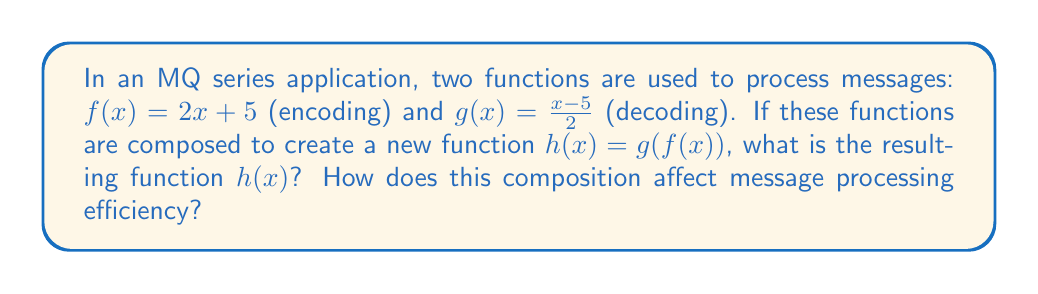Provide a solution to this math problem. To solve this problem, we need to compose the functions $f(x)$ and $g(x)$ to create $h(x)$:

1. Start with $h(x) = g(f(x))$
2. Replace $f(x)$ with its definition: $h(x) = g(2x + 5)$
3. Now apply function $g$ to this result:
   $h(x) = \frac{(2x + 5) - 5}{2}$
4. Simplify the numerator:
   $h(x) = \frac{2x}{2}$
5. Cancel out the common factor of 2:
   $h(x) = x$

The resulting function $h(x) = x$ is the identity function. This means that composing the encoding and decoding functions effectively cancels out their operations.

In terms of message processing efficiency, this composition eliminates the need for separate encoding and decoding steps, as $h(x)$ simply returns the original input. This can significantly reduce processing time and resource usage in high-performance MQ series applications, especially when dealing with large volumes of messages.
Answer: $h(x) = x$ 